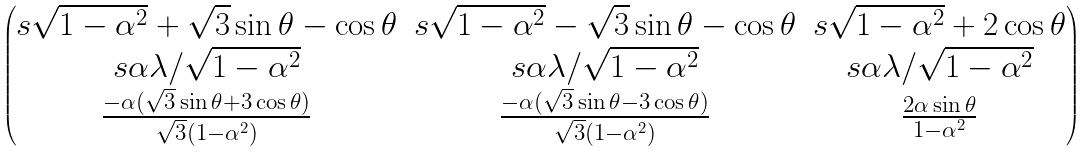<formula> <loc_0><loc_0><loc_500><loc_500>\begin{pmatrix} s \sqrt { 1 - \alpha ^ { 2 } } + \sqrt { 3 } \sin \theta - \cos \theta & s \sqrt { 1 - \alpha ^ { 2 } } - \sqrt { 3 } \sin \theta - \cos \theta & s \sqrt { 1 - \alpha ^ { 2 } } + 2 \cos \theta \\ s \alpha \lambda / \sqrt { 1 - \alpha ^ { 2 } } & s \alpha \lambda / \sqrt { 1 - \alpha ^ { 2 } } & s \alpha \lambda / \sqrt { 1 - \alpha ^ { 2 } } \\ \frac { - \alpha ( \sqrt { 3 } \sin \theta + 3 \cos \theta ) } { \sqrt { 3 } ( 1 - \alpha ^ { 2 } ) } & \frac { - \alpha ( \sqrt { 3 } \sin \theta - 3 \cos \theta ) } { \sqrt { 3 } ( 1 - \alpha ^ { 2 } ) } & \frac { 2 \alpha \sin \theta } { 1 - \alpha ^ { 2 } } \end{pmatrix}</formula> 